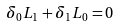<formula> <loc_0><loc_0><loc_500><loc_500>\delta _ { 0 } L _ { 1 } + \delta _ { 1 } L _ { 0 } = 0</formula> 